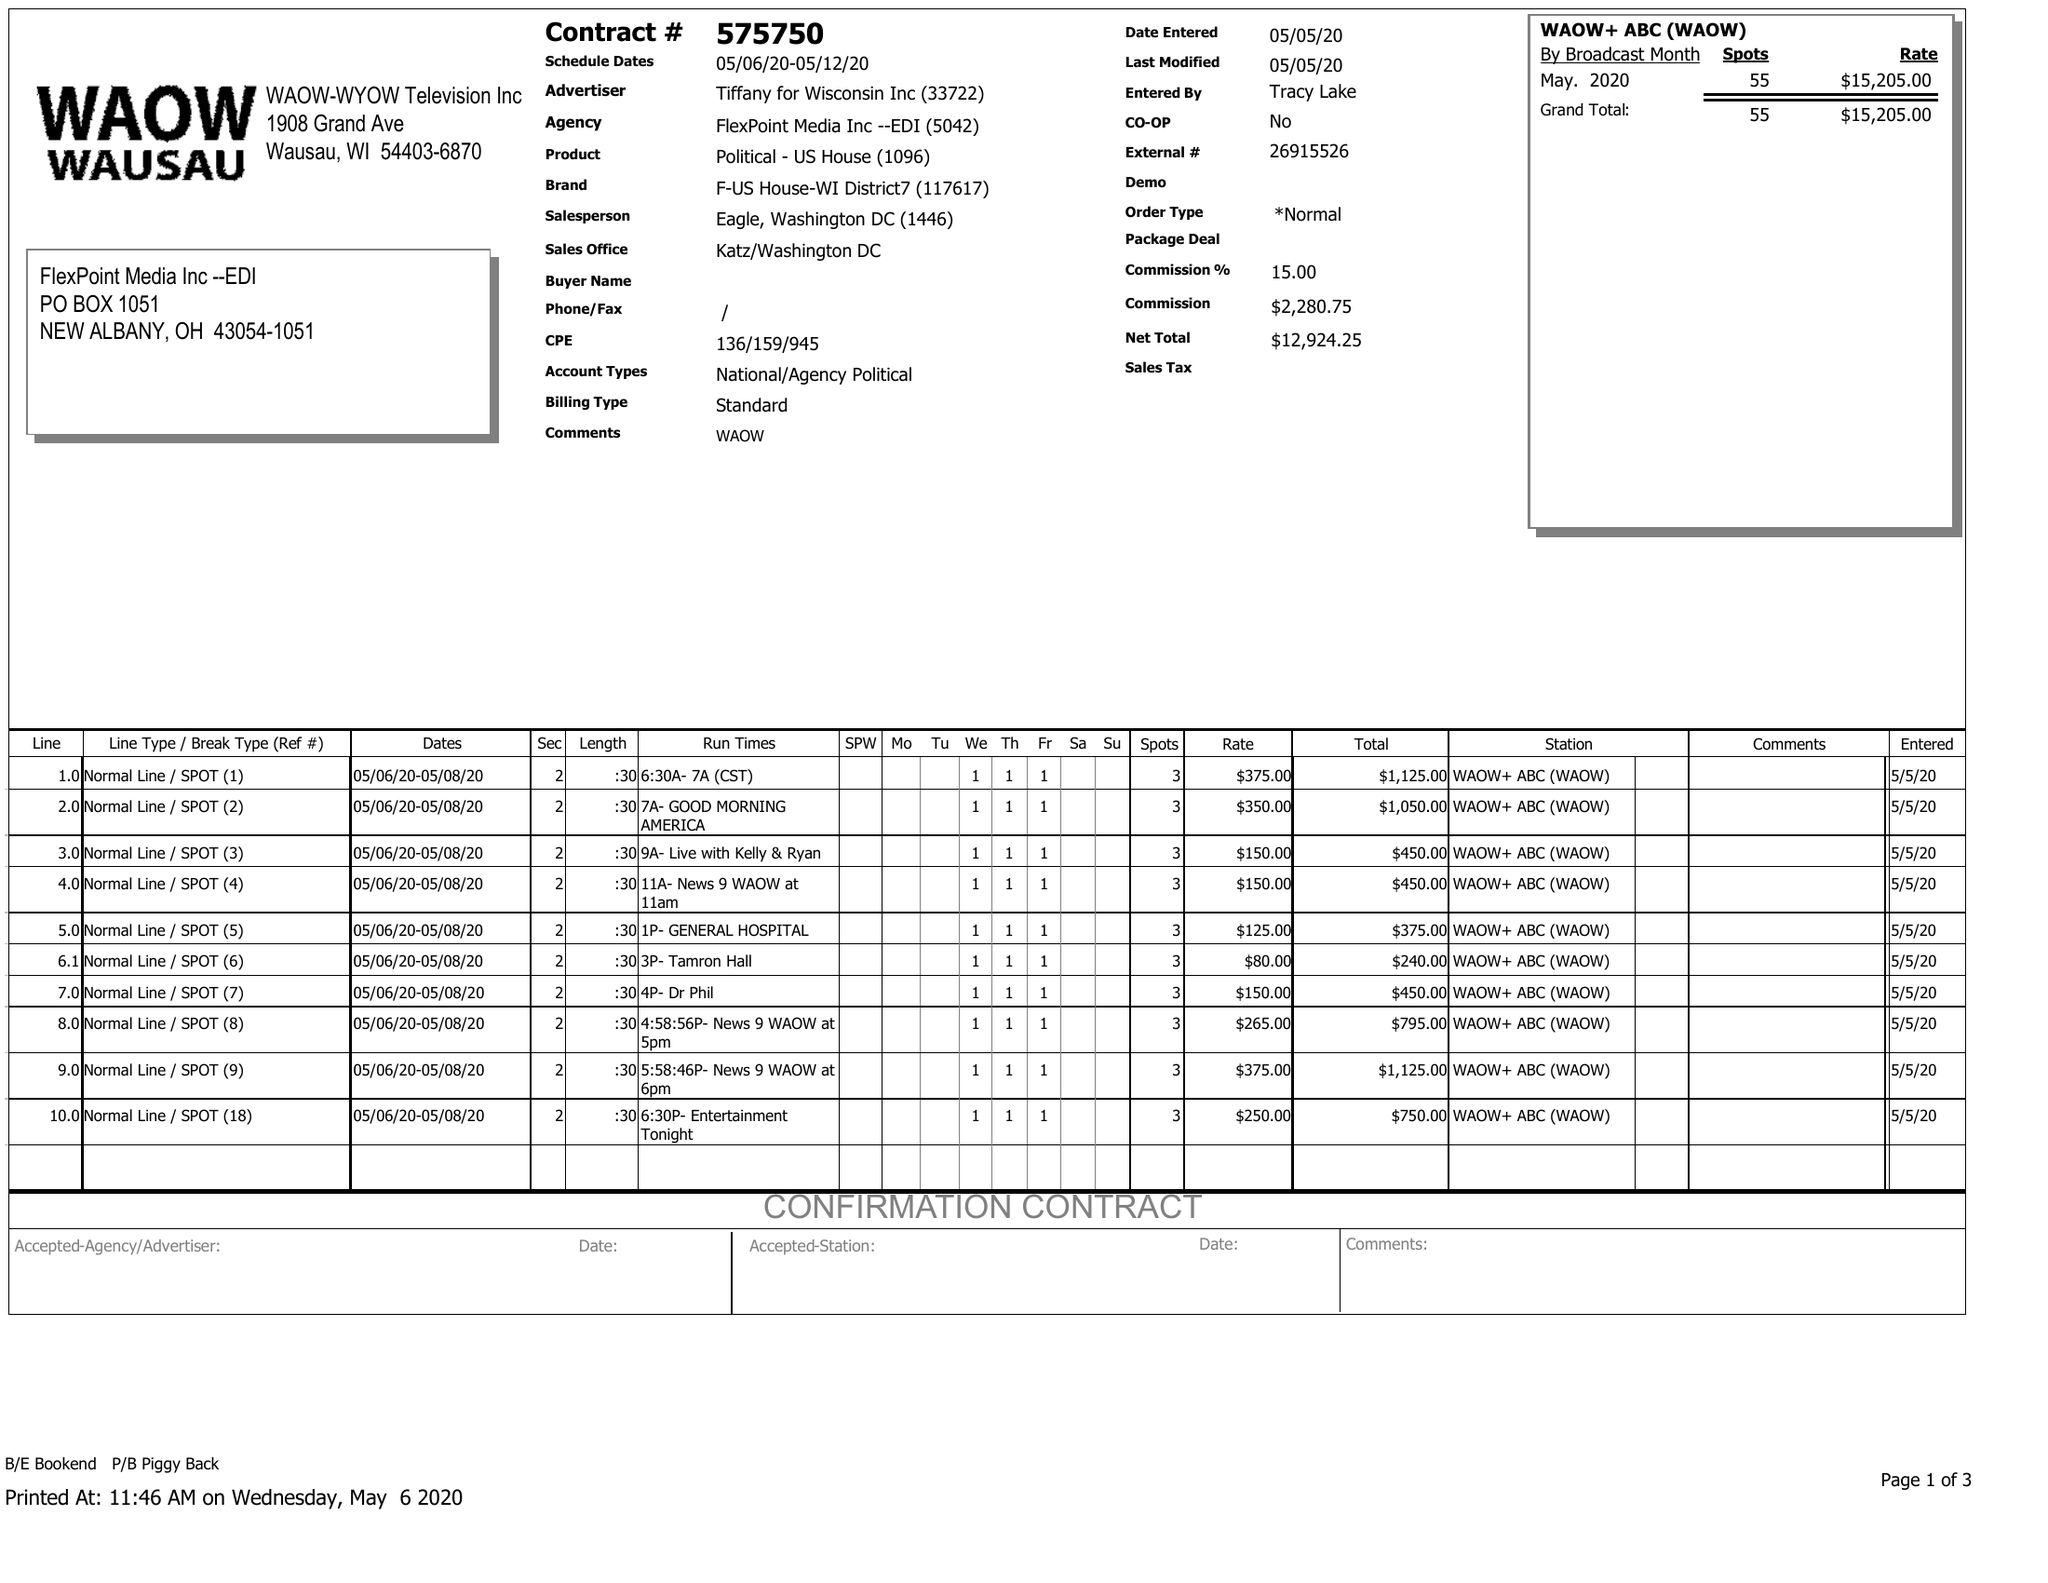What is the value for the contract_num?
Answer the question using a single word or phrase. 575750 